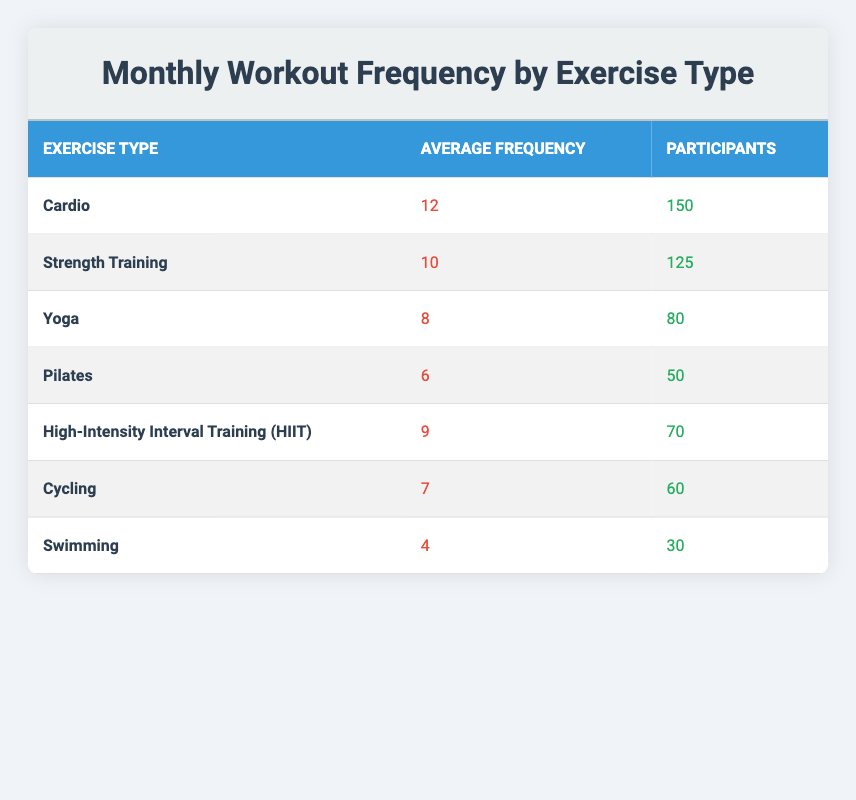What is the average frequency of Cardio workouts? The average frequency of Cardio workouts is listed in the table under the "Average Frequency" column for Cardio, which is 12.
Answer: 12 How many participants are involved in Strength Training? The number of participants involved in Strength Training is directly available in the "Participants" column for Strength Training, which states 125 participants.
Answer: 125 Which exercise type has the lowest average frequency? By comparing the "Average Frequency" values, Swimming has the lowest average frequency at 4.
Answer: Swimming What is the total average frequency of all exercise types listed? To find the total, sum the average frequencies: 12 (Cardio) + 10 (Strength Training) + 8 (Yoga) + 6 (Pilates) + 9 (HIIT) + 7 (Cycling) + 4 (Swimming) = 56, then divide by the number of exercise types (7) to get the average of 8.
Answer: 8 Is the number of participants for Yoga greater than that for Pilates? Yes, the "Participants" value for Yoga is 80, which is greater than 50, the "Participants" value for Pilates.
Answer: Yes What is the difference in average frequency between Cardio and Pilates? The average frequency for Cardio is 12 and for Pilates is 6. The difference is 12 - 6 = 6.
Answer: 6 How many total participants are involved in both Cycling and Swimming exercises combined? Add the participants for Cycling (60) and Swimming (30): 60 + 30 = 90.
Answer: 90 Which exercise type has more participants, HIIT or Yoga? HIIT has 70 participants while Yoga has 80 participants. Since 80 is greater than 70, Yoga has more participants.
Answer: No What is the average number of participants for the top three exercise types by frequency? Identify the top three by average frequency: Cardio (150), Strength Training (125), and Yoga (80). Sum them up: 150 + 125 + 80 = 355 and then divide by 3 for the average, which is 118.33. The average number of participants for the top three exercise types is approximately 118.
Answer: 118.33 Does the number of participants for HIIT exercise exceed that of Swimming? Yes, HIIT has 70 participants while Swimming has only 30, so HIIT's participants exceed that of Swimming.
Answer: Yes 